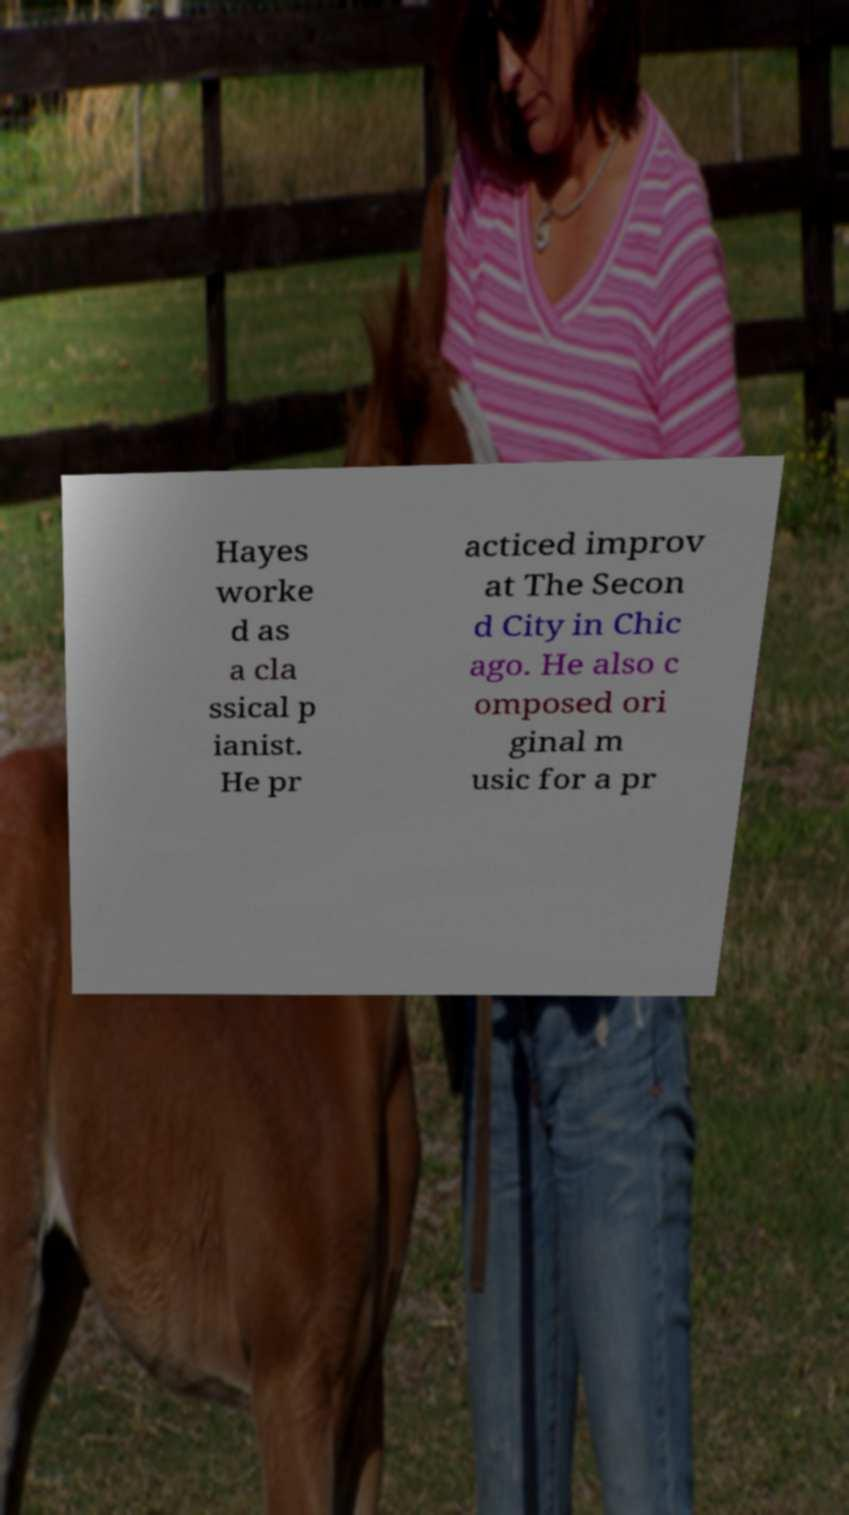For documentation purposes, I need the text within this image transcribed. Could you provide that? Hayes worke d as a cla ssical p ianist. He pr acticed improv at The Secon d City in Chic ago. He also c omposed ori ginal m usic for a pr 